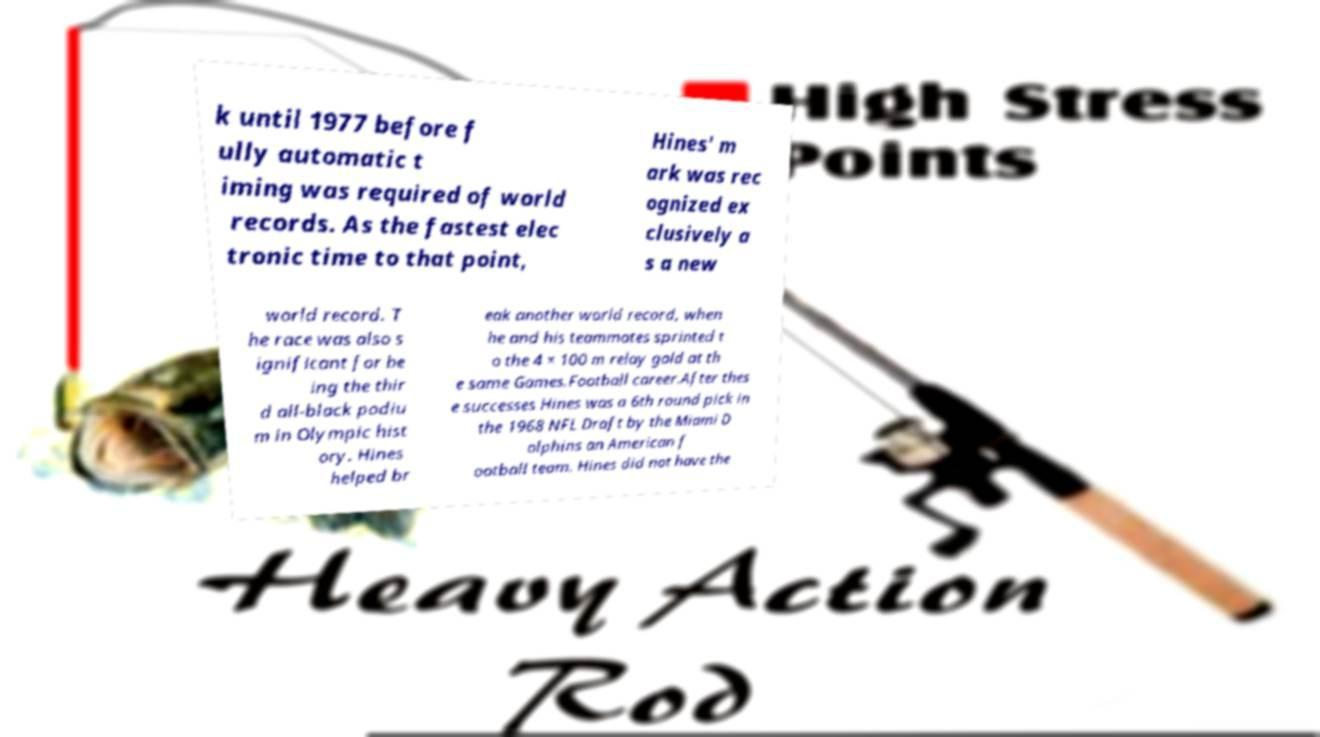Could you extract and type out the text from this image? k until 1977 before f ully automatic t iming was required of world records. As the fastest elec tronic time to that point, Hines' m ark was rec ognized ex clusively a s a new world record. T he race was also s ignificant for be ing the thir d all-black podiu m in Olympic hist ory. Hines helped br eak another world record, when he and his teammates sprinted t o the 4 × 100 m relay gold at th e same Games.Football career.After thes e successes Hines was a 6th round pick in the 1968 NFL Draft by the Miami D olphins an American f ootball team. Hines did not have the 